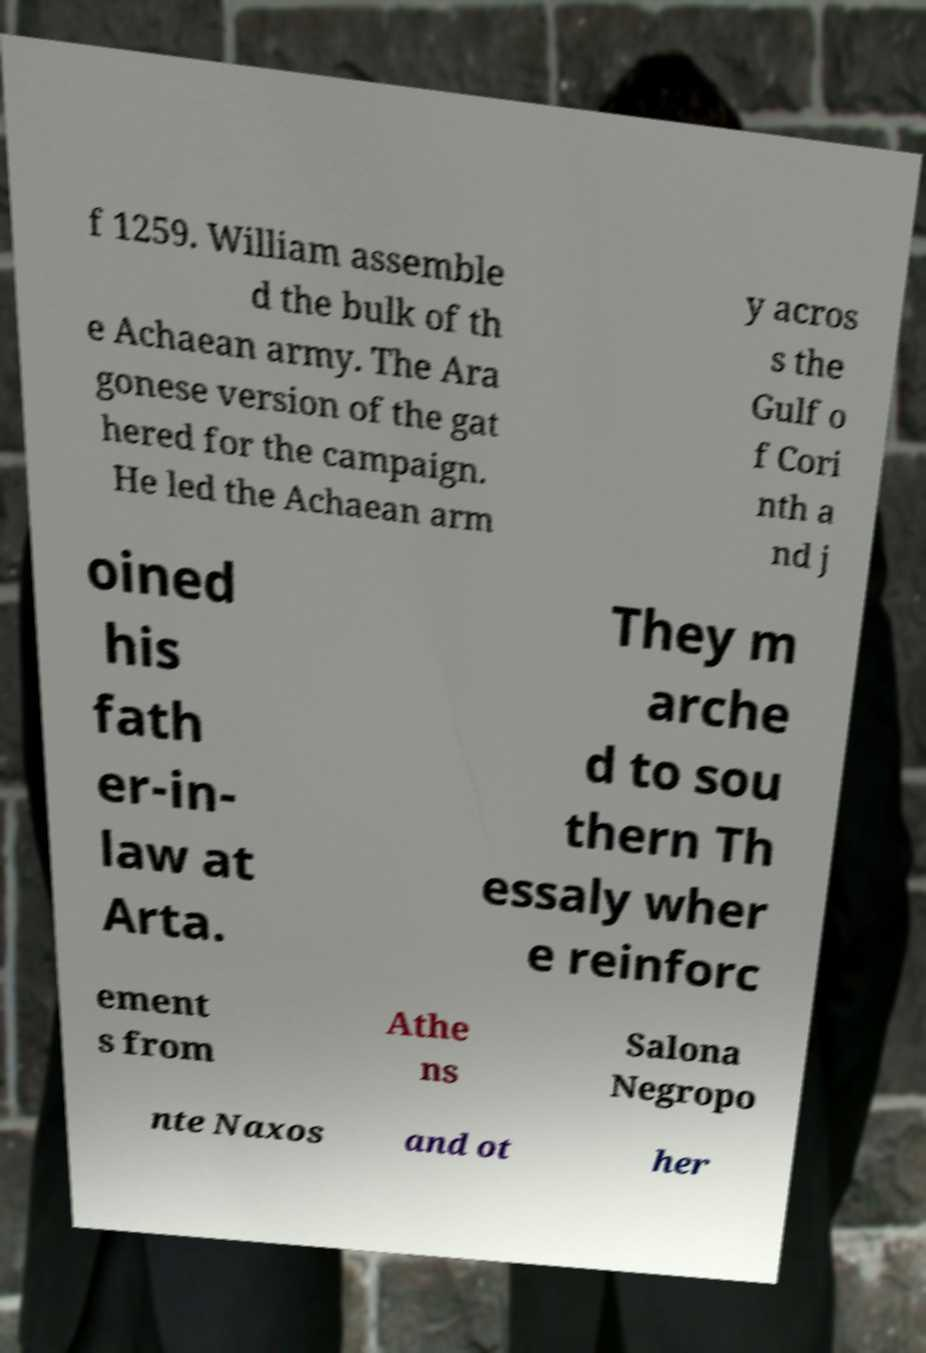There's text embedded in this image that I need extracted. Can you transcribe it verbatim? f 1259. William assemble d the bulk of th e Achaean army. The Ara gonese version of the gat hered for the campaign. He led the Achaean arm y acros s the Gulf o f Cori nth a nd j oined his fath er-in- law at Arta. They m arche d to sou thern Th essaly wher e reinforc ement s from Athe ns Salona Negropo nte Naxos and ot her 